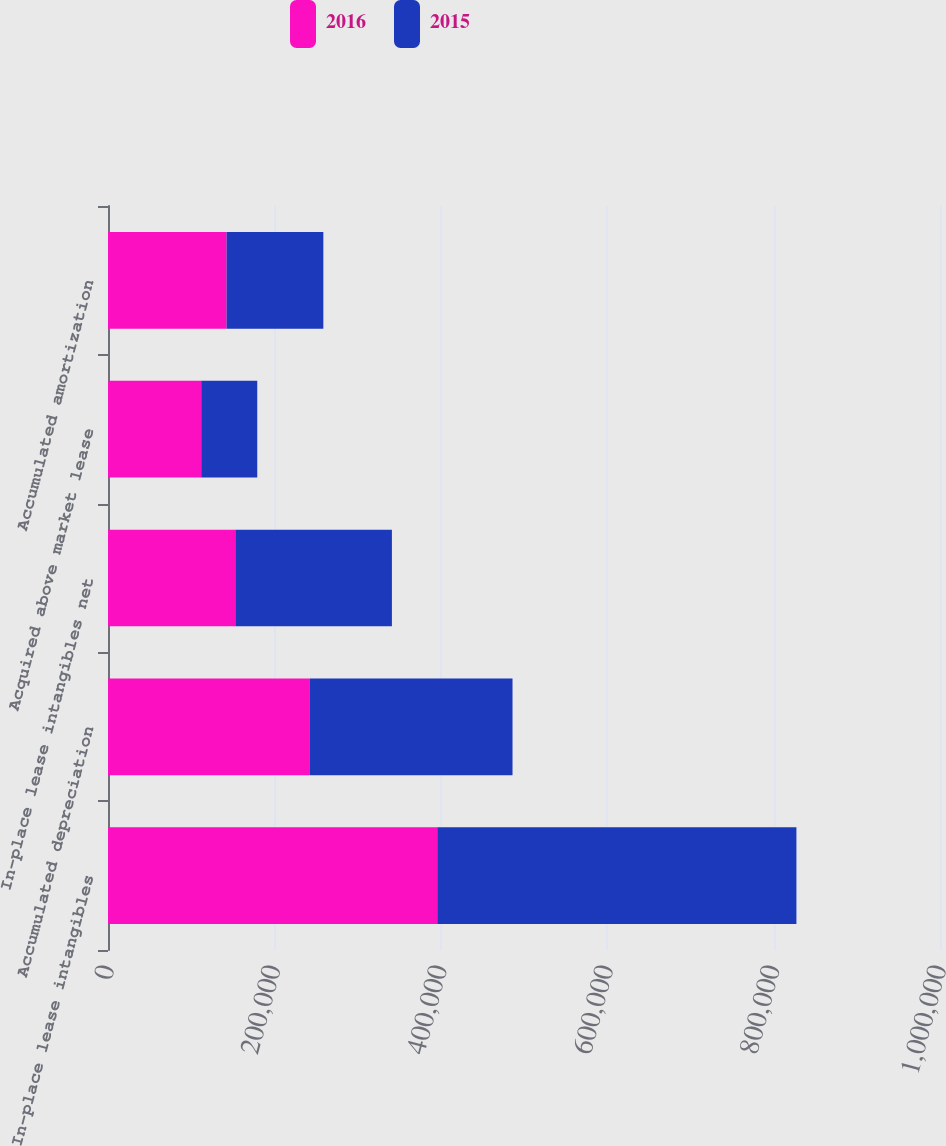<chart> <loc_0><loc_0><loc_500><loc_500><stacked_bar_chart><ecel><fcel>In-place lease intangibles<fcel>Accumulated depreciation<fcel>In-place lease intangibles net<fcel>Acquired above market lease<fcel>Accumulated amortization<nl><fcel>2016<fcel>395713<fcel>242698<fcel>153015<fcel>112024<fcel>142557<nl><fcel>2015<fcel>431712<fcel>243493<fcel>188219<fcel>67363<fcel>116262<nl></chart> 